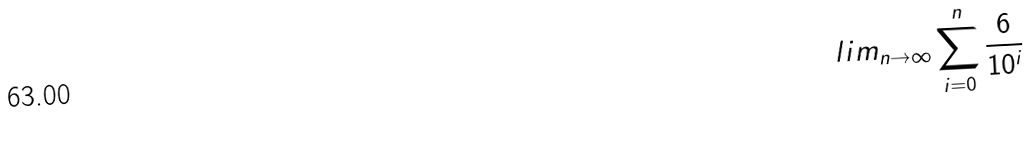Convert formula to latex. <formula><loc_0><loc_0><loc_500><loc_500>l i m _ { n \rightarrow \infty } \sum _ { i = 0 } ^ { n } \frac { 6 } { 1 0 ^ { i } }</formula> 